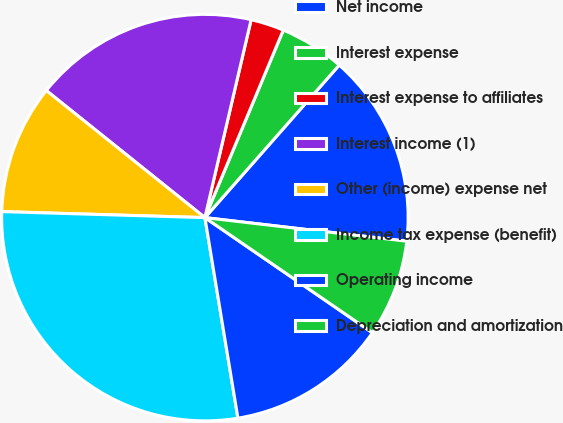Convert chart to OTSL. <chart><loc_0><loc_0><loc_500><loc_500><pie_chart><fcel>Net income<fcel>Interest expense<fcel>Interest expense to affiliates<fcel>Interest income (1)<fcel>Other (income) expense net<fcel>Income tax expense (benefit)<fcel>Operating income<fcel>Depreciation and amortization<nl><fcel>15.36%<fcel>5.19%<fcel>2.65%<fcel>17.9%<fcel>10.28%<fcel>28.07%<fcel>12.82%<fcel>7.73%<nl></chart> 